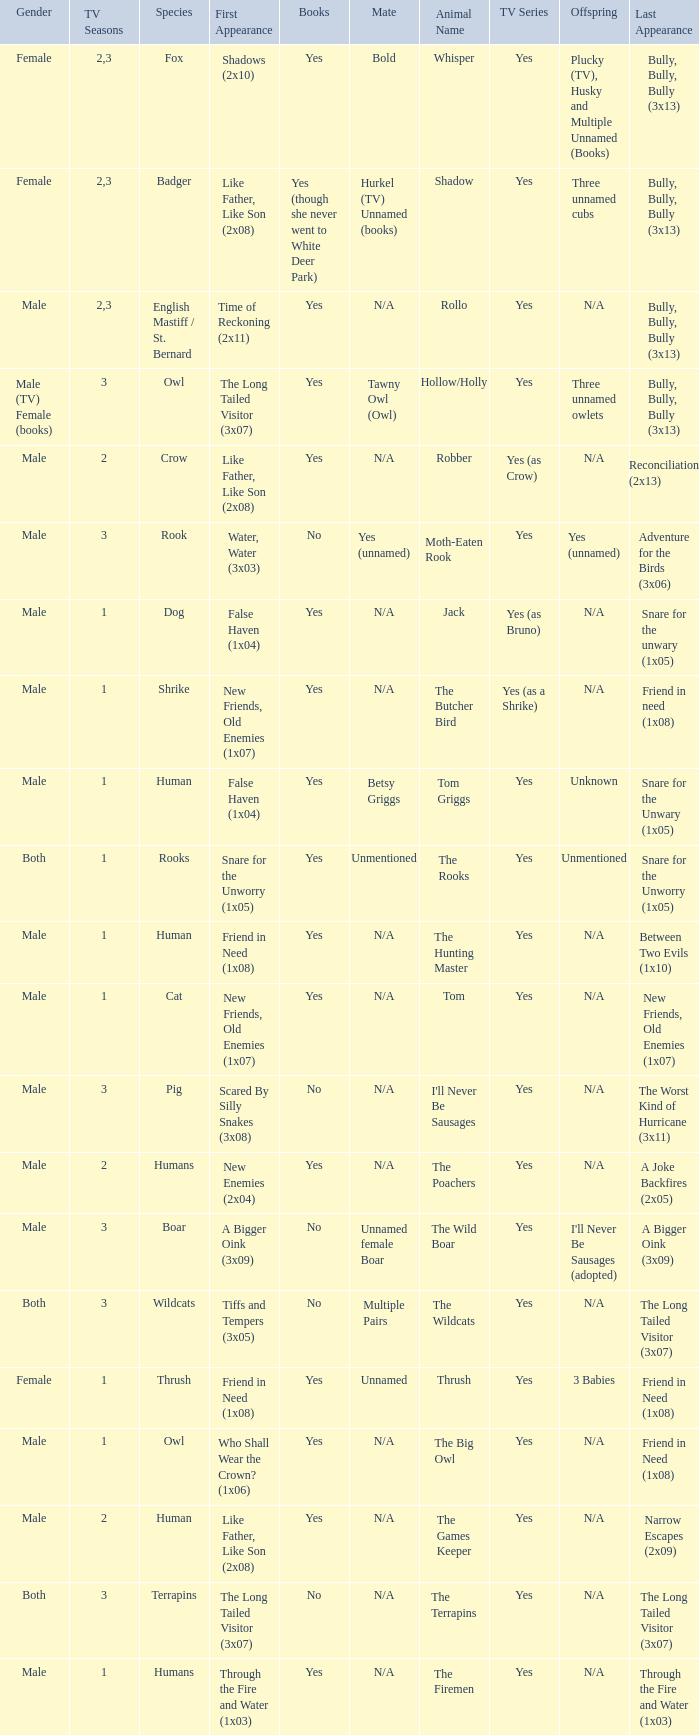What show has a boar? Yes. Could you parse the entire table? {'header': ['Gender', 'TV Seasons', 'Species', 'First Appearance', 'Books', 'Mate', 'Animal Name', 'TV Series', 'Offspring', 'Last Appearance'], 'rows': [['Female', '2,3', 'Fox', 'Shadows (2x10)', 'Yes', 'Bold', 'Whisper', 'Yes', 'Plucky (TV), Husky and Multiple Unnamed (Books)', 'Bully, Bully, Bully (3x13)'], ['Female', '2,3', 'Badger', 'Like Father, Like Son (2x08)', 'Yes (though she never went to White Deer Park)', 'Hurkel (TV) Unnamed (books)', 'Shadow', 'Yes', 'Three unnamed cubs', 'Bully, Bully, Bully (3x13)'], ['Male', '2,3', 'English Mastiff / St. Bernard', 'Time of Reckoning (2x11)', 'Yes', 'N/A', 'Rollo', 'Yes', 'N/A', 'Bully, Bully, Bully (3x13)'], ['Male (TV) Female (books)', '3', 'Owl', 'The Long Tailed Visitor (3x07)', 'Yes', 'Tawny Owl (Owl)', 'Hollow/Holly', 'Yes', 'Three unnamed owlets', 'Bully, Bully, Bully (3x13)'], ['Male', '2', 'Crow', 'Like Father, Like Son (2x08)', 'Yes', 'N/A', 'Robber', 'Yes (as Crow)', 'N/A', 'Reconciliation (2x13)'], ['Male', '3', 'Rook', 'Water, Water (3x03)', 'No', 'Yes (unnamed)', 'Moth-Eaten Rook', 'Yes', 'Yes (unnamed)', 'Adventure for the Birds (3x06)'], ['Male', '1', 'Dog', 'False Haven (1x04)', 'Yes', 'N/A', 'Jack', 'Yes (as Bruno)', 'N/A', 'Snare for the unwary (1x05)'], ['Male', '1', 'Shrike', 'New Friends, Old Enemies (1x07)', 'Yes', 'N/A', 'The Butcher Bird', 'Yes (as a Shrike)', 'N/A', 'Friend in need (1x08)'], ['Male', '1', 'Human', 'False Haven (1x04)', 'Yes', 'Betsy Griggs', 'Tom Griggs', 'Yes', 'Unknown', 'Snare for the Unwary (1x05)'], ['Both', '1', 'Rooks', 'Snare for the Unworry (1x05)', 'Yes', 'Unmentioned', 'The Rooks', 'Yes', 'Unmentioned', 'Snare for the Unworry (1x05)'], ['Male', '1', 'Human', 'Friend in Need (1x08)', 'Yes', 'N/A', 'The Hunting Master', 'Yes', 'N/A', 'Between Two Evils (1x10)'], ['Male', '1', 'Cat', 'New Friends, Old Enemies (1x07)', 'Yes', 'N/A', 'Tom', 'Yes', 'N/A', 'New Friends, Old Enemies (1x07)'], ['Male', '3', 'Pig', 'Scared By Silly Snakes (3x08)', 'No', 'N/A', "I'll Never Be Sausages", 'Yes', 'N/A', 'The Worst Kind of Hurricane (3x11)'], ['Male', '2', 'Humans', 'New Enemies (2x04)', 'Yes', 'N/A', 'The Poachers', 'Yes', 'N/A', 'A Joke Backfires (2x05)'], ['Male', '3', 'Boar', 'A Bigger Oink (3x09)', 'No', 'Unnamed female Boar', 'The Wild Boar', 'Yes', "I'll Never Be Sausages (adopted)", 'A Bigger Oink (3x09)'], ['Both', '3', 'Wildcats', 'Tiffs and Tempers (3x05)', 'No', 'Multiple Pairs', 'The Wildcats', 'Yes', 'N/A', 'The Long Tailed Visitor (3x07)'], ['Female', '1', 'Thrush', 'Friend in Need (1x08)', 'Yes', 'Unnamed', 'Thrush', 'Yes', '3 Babies', 'Friend in Need (1x08)'], ['Male', '1', 'Owl', 'Who Shall Wear the Crown? (1x06)', 'Yes', 'N/A', 'The Big Owl', 'Yes', 'N/A', 'Friend in Need (1x08)'], ['Male', '2', 'Human', 'Like Father, Like Son (2x08)', 'Yes', 'N/A', 'The Games Keeper', 'Yes', 'N/A', 'Narrow Escapes (2x09)'], ['Both', '3', 'Terrapins', 'The Long Tailed Visitor (3x07)', 'No', 'N/A', 'The Terrapins', 'Yes', 'N/A', 'The Long Tailed Visitor (3x07)'], ['Male', '1', 'Humans', 'Through the Fire and Water (1x03)', 'Yes', 'N/A', 'The Firemen', 'Yes', 'N/A', 'Through the Fire and Water (1x03)']]} 